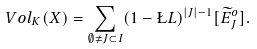<formula> <loc_0><loc_0><loc_500><loc_500>\ V o l _ { K } ( X ) = \sum _ { \emptyset \neq J \subset I } ( 1 - \L L ) ^ { | J | - 1 } [ \widetilde { E } _ { J } ^ { o } ] .</formula> 